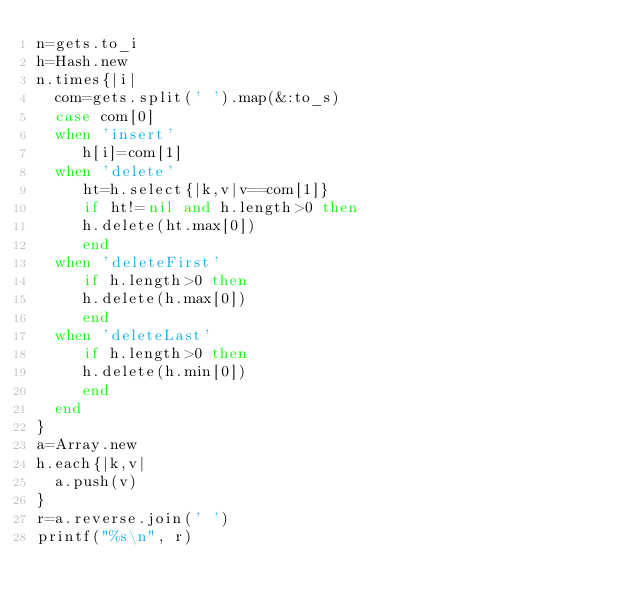<code> <loc_0><loc_0><loc_500><loc_500><_Ruby_>n=gets.to_i
h=Hash.new
n.times{|i|
  com=gets.split(' ').map(&:to_s)
  case com[0]
  when 'insert'
     h[i]=com[1]
  when 'delete'
     ht=h.select{|k,v|v==com[1]}
     if ht!=nil and h.length>0 then
     h.delete(ht.max[0])
     end
  when 'deleteFirst'
     if h.length>0 then
     h.delete(h.max[0])
     end
  when 'deleteLast'
     if h.length>0 then
     h.delete(h.min[0])
     end
  end
}
a=Array.new
h.each{|k,v|
  a.push(v)
}
r=a.reverse.join(' ')
printf("%s\n", r)</code> 